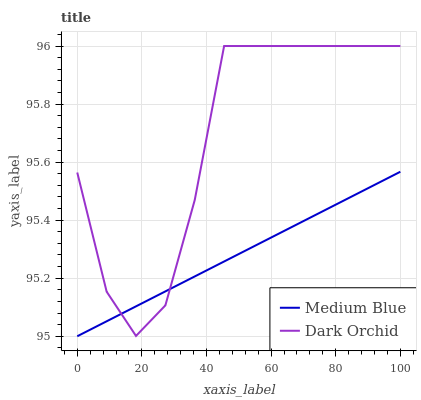Does Medium Blue have the minimum area under the curve?
Answer yes or no. Yes. Does Dark Orchid have the maximum area under the curve?
Answer yes or no. Yes. Does Dark Orchid have the minimum area under the curve?
Answer yes or no. No. Is Medium Blue the smoothest?
Answer yes or no. Yes. Is Dark Orchid the roughest?
Answer yes or no. Yes. Is Dark Orchid the smoothest?
Answer yes or no. No. Does Dark Orchid have the lowest value?
Answer yes or no. No. 